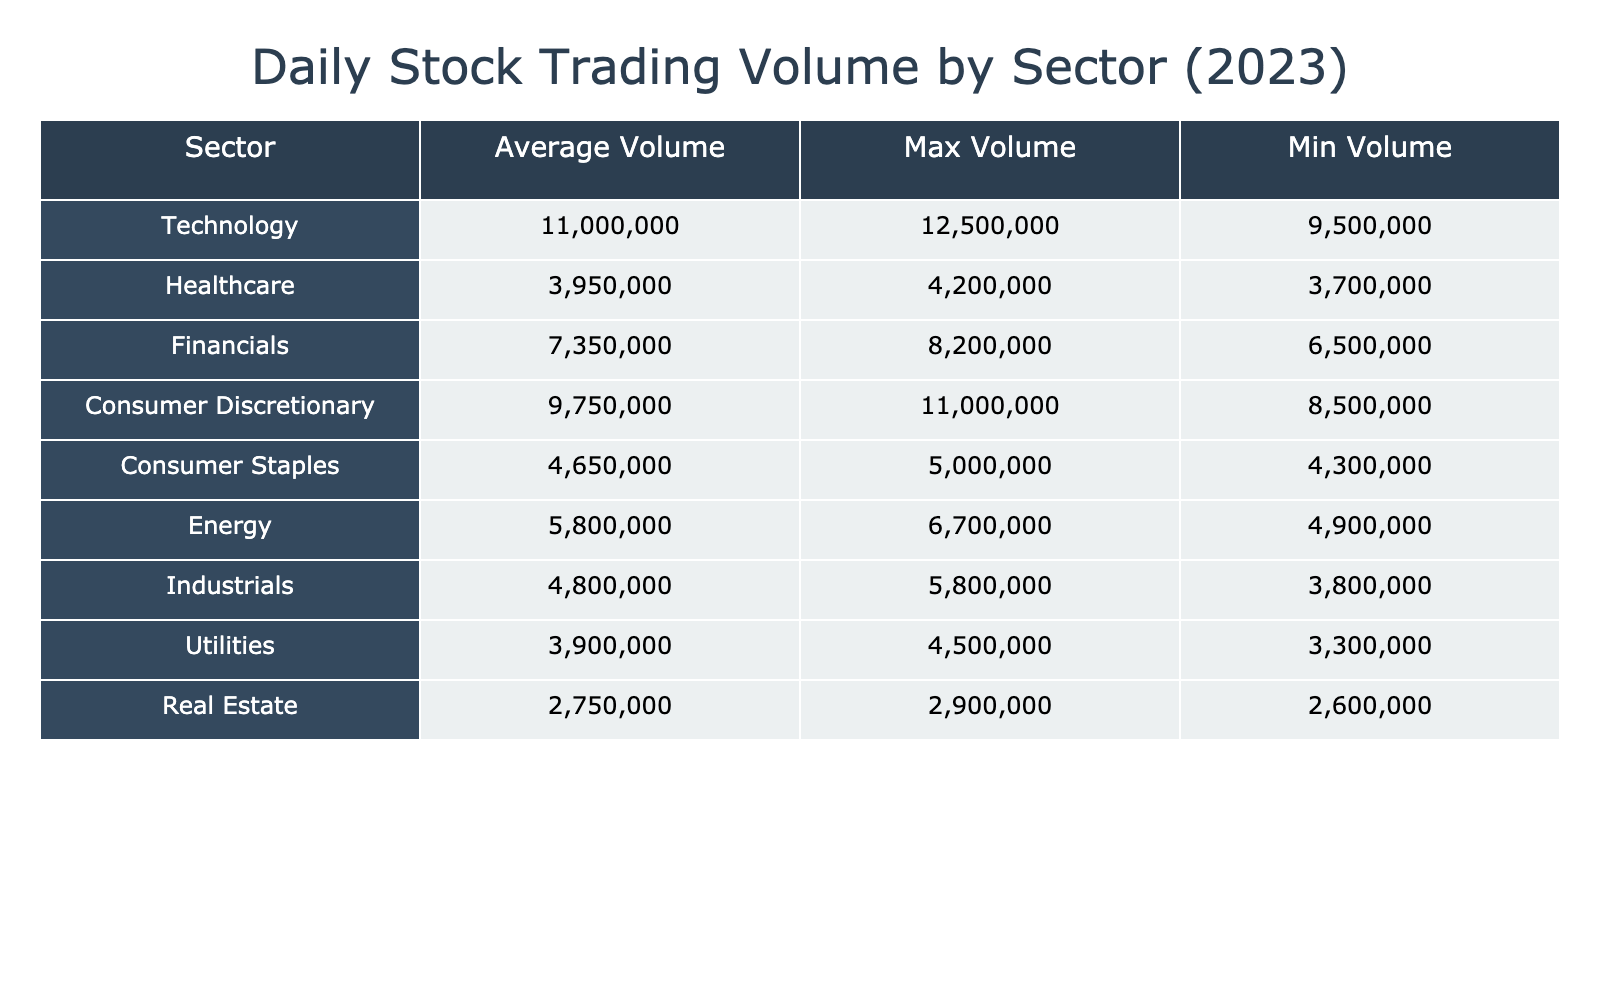What is the average daily trading volume for the Technology sector? The Technology sector includes Apple Inc. with 12,500,000 shares and Microsoft Corp. with 9,500,000 shares. The average is calculated as (12,500,000 + 9,500,000) / 2 = 11,000,000 shares.
Answer: 11,000,000 shares Which sector has the highest maximum trading volume? To find the sector with the highest maximum trading volume, we look at the maximum trading volumes for each sector. The maximum for Technology is 12,500,000, for Healthcare is 4,200,000, for Financials is 8,200,000, for Consumer Discretionary is 11,000,000, for Consumer Staples is 5,000,000, for Energy is 6,700,000, for Industrials is 5,800,000, for Utilities is 4,500,000, and for Real Estate is 2,900,000. The highest is 12,500,000 in the Technology sector.
Answer: Technology Is the average daily trading volume for the Consumer Discretionary sector greater than that of the Healthcare sector? The average daily trading volume for Consumer Discretionary is calculated as (11,000,000 + 8,500,000) / 2 = 9,750,000 shares. For Healthcare, it is (4,200,000 + 3,700,000) / 2 = 3,950,000 shares. Since 9,750,000 is greater than 3,950,000, the answer is yes.
Answer: Yes What is the difference between the maximum trading volumes of the Energy and Financials sectors? The maximum trading volume for the Energy sector is 6,700,000 shares (Exxon Mobil Corp.), and for Financials, it is 8,200,000 shares (JPMorgan Chase & Co.). The difference is calculated as 8,200,000 - 6,700,000 = 1,500,000 shares.
Answer: 1,500,000 shares Does the Consumer Staples sector have a lower minimum trading volume than the Real Estate sector? The minimum trading volume for Consumer Staples is 4,300,000 shares (Coca-Cola Co.), while for Real Estate it is 2,600,000 shares (Prologis Inc.). Since 4,300,000 is greater than 2,600,000, the answer is no.
Answer: No Which sector has a higher average trading volume: Utilities or Industrials? The average for Utilities is (3,300,000 + 4,500,000) / 2 = 3,900,000 shares. For Industrials, it is (5,800,000 + 3,800,000) / 2 = 4,800,000 shares. Since 4,800,000 is greater than 3,900,000, the Industrials sector has a higher average.
Answer: Industrials 